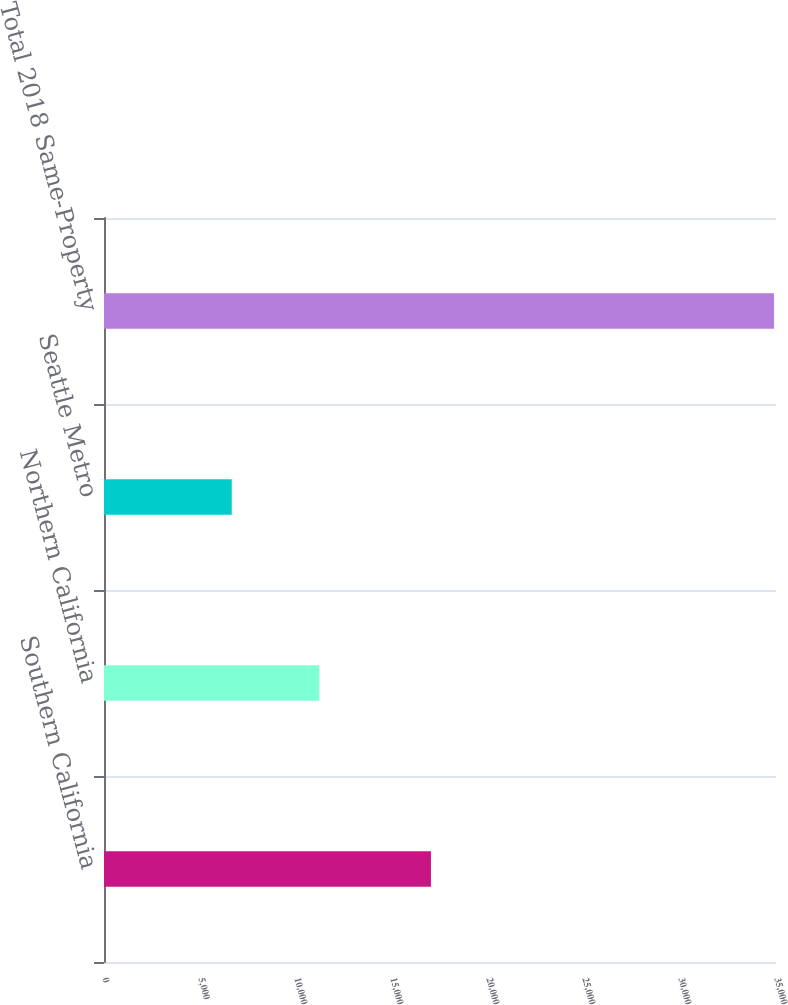Convert chart to OTSL. <chart><loc_0><loc_0><loc_500><loc_500><bar_chart><fcel>Southern California<fcel>Northern California<fcel>Seattle Metro<fcel>Total 2018 Same-Property<nl><fcel>17028<fcel>11216<fcel>6653<fcel>34897<nl></chart> 